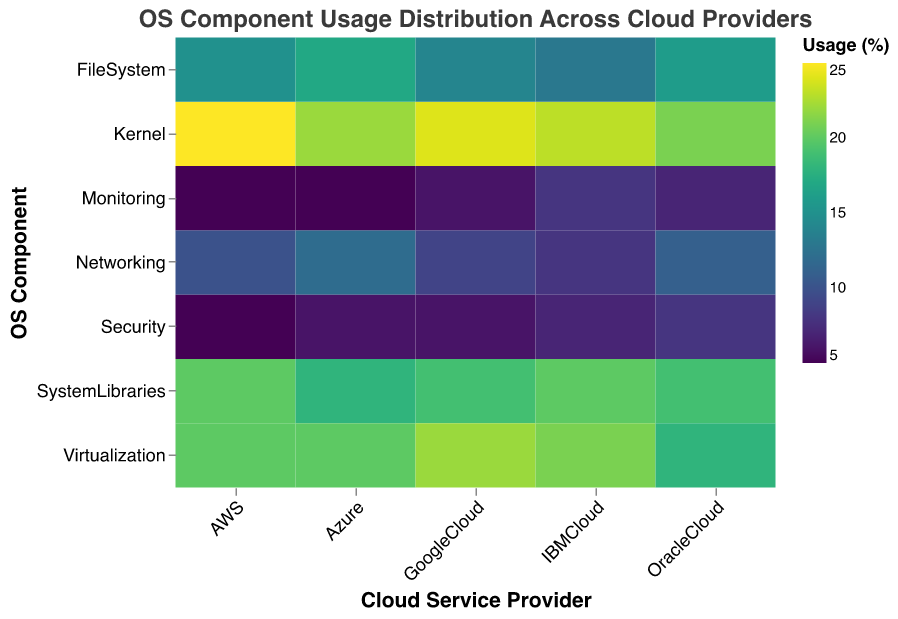What is the title of the heatmap? The title of the heatmap is usually placed at the top of the plot and is meant to describe what the heatmap is representing. In this case, the title is clearly mentioned in the provided code.
Answer: OS Component Usage Distribution Across Cloud Providers Which OS Component has the highest usage on AWS? To identify the highest usage component on AWS, we look at the column labeled "AWS" and find the box with the darkest color, which corresponds to the highest numerical value.
Answer: Kernel (25%) Compare the usage of the Kernel component between Azure and IBMCloud. Which one has a higher percentage? Notice the color shades of the "Kernel" row under both "Azure" and "IBMCloud". Darker colors indicate higher usage percentages. From the data, Azure has 22% and IBMCloud has 23%, so IBMCloud has a higher Kernel usage.
Answer: IBMCloud What is the overall trend in the usage of Virtualization across all service providers? Analyzing the shades of the cells in the "Virtualization" row for all service providers will reveal the trend. All values are above 18%, with Google Cloud having the highest at 22%.
Answer: High usage across all providers Which cloud service provider has the least usage for the Networking component? By comparing the colors in the "Networking" row, the lightest color indicates the lowest usage. IBMCloud has the lightest color in this row, corresponding to 8% usage.
Answer: IBMCloud (8%) What is the average usage percentage of the System Libraries component across all service providers? Add the percentages of System Libraries usage for all providers and then divide by the number of providers. The percentages are: 20 (AWS) + 18 (Azure) + 19 (Google Cloud) + 20 (IBMCloud) + 19 (OracleCloud). The total is 96%, divided by 5 providers, so the average is 96/5 = 19.2%.
Answer: 19.2% Which OS component shows the highest variability in usage across different service providers? To determine variability, look for components with a wide range of shaded colors, indicating large differences in percentages. Kernel usage varies between 21% and 25%, while components like Security range between 5% and 8%, indicating Kernel has higher variability.
Answer: Kernel Is there any component where all service providers have the same usage percentage? Review each row to see if all cells have the same color/shade, indicating the same value. Monitoring shows 5-8% use, not equal. By examining all rows, no component has the same exact percentage across all providers.
Answer: No What insights can be drawn about the focus on Security among the service providers? By analyzing the shades in the Security row, it's clear that security usage is relatively low across all providers, ranging from 5% to 8%. This suggests a lesser focus compared to other components like Kernel and Virtualization.
Answer: Security usage is consistently low 